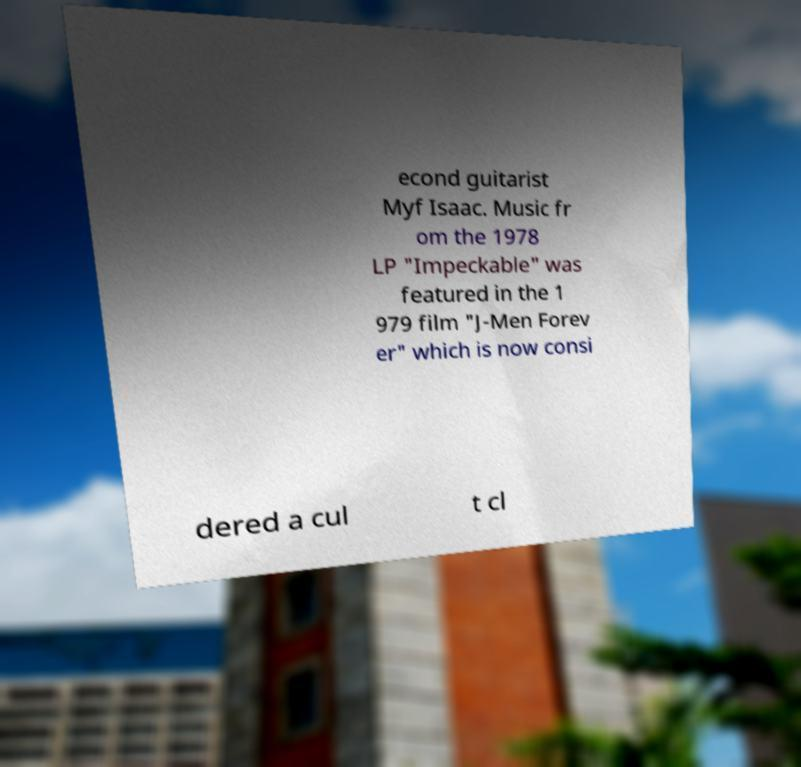What messages or text are displayed in this image? I need them in a readable, typed format. econd guitarist Myf Isaac. Music fr om the 1978 LP "Impeckable" was featured in the 1 979 film "J-Men Forev er" which is now consi dered a cul t cl 